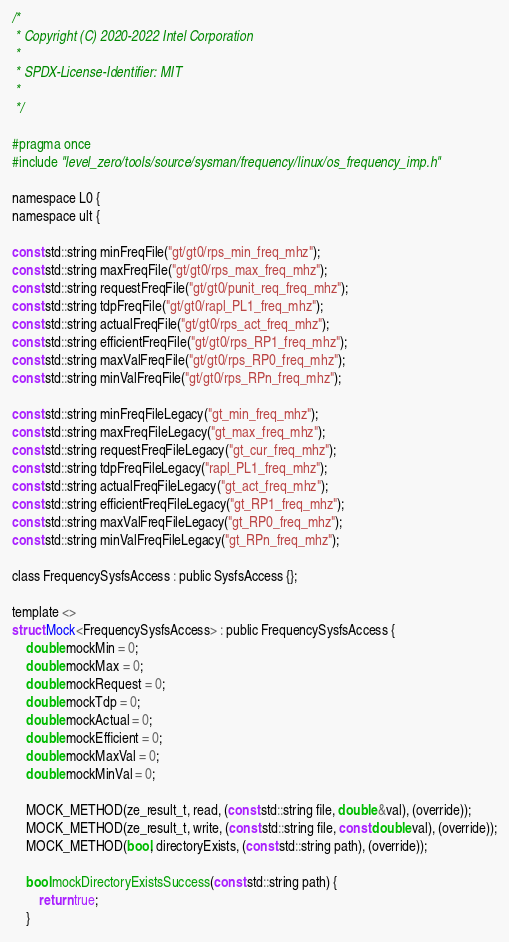<code> <loc_0><loc_0><loc_500><loc_500><_C_>/*
 * Copyright (C) 2020-2022 Intel Corporation
 *
 * SPDX-License-Identifier: MIT
 *
 */

#pragma once
#include "level_zero/tools/source/sysman/frequency/linux/os_frequency_imp.h"

namespace L0 {
namespace ult {

const std::string minFreqFile("gt/gt0/rps_min_freq_mhz");
const std::string maxFreqFile("gt/gt0/rps_max_freq_mhz");
const std::string requestFreqFile("gt/gt0/punit_req_freq_mhz");
const std::string tdpFreqFile("gt/gt0/rapl_PL1_freq_mhz");
const std::string actualFreqFile("gt/gt0/rps_act_freq_mhz");
const std::string efficientFreqFile("gt/gt0/rps_RP1_freq_mhz");
const std::string maxValFreqFile("gt/gt0/rps_RP0_freq_mhz");
const std::string minValFreqFile("gt/gt0/rps_RPn_freq_mhz");

const std::string minFreqFileLegacy("gt_min_freq_mhz");
const std::string maxFreqFileLegacy("gt_max_freq_mhz");
const std::string requestFreqFileLegacy("gt_cur_freq_mhz");
const std::string tdpFreqFileLegacy("rapl_PL1_freq_mhz");
const std::string actualFreqFileLegacy("gt_act_freq_mhz");
const std::string efficientFreqFileLegacy("gt_RP1_freq_mhz");
const std::string maxValFreqFileLegacy("gt_RP0_freq_mhz");
const std::string minValFreqFileLegacy("gt_RPn_freq_mhz");

class FrequencySysfsAccess : public SysfsAccess {};

template <>
struct Mock<FrequencySysfsAccess> : public FrequencySysfsAccess {
    double mockMin = 0;
    double mockMax = 0;
    double mockRequest = 0;
    double mockTdp = 0;
    double mockActual = 0;
    double mockEfficient = 0;
    double mockMaxVal = 0;
    double mockMinVal = 0;

    MOCK_METHOD(ze_result_t, read, (const std::string file, double &val), (override));
    MOCK_METHOD(ze_result_t, write, (const std::string file, const double val), (override));
    MOCK_METHOD(bool, directoryExists, (const std::string path), (override));

    bool mockDirectoryExistsSuccess(const std::string path) {
        return true;
    }
</code> 